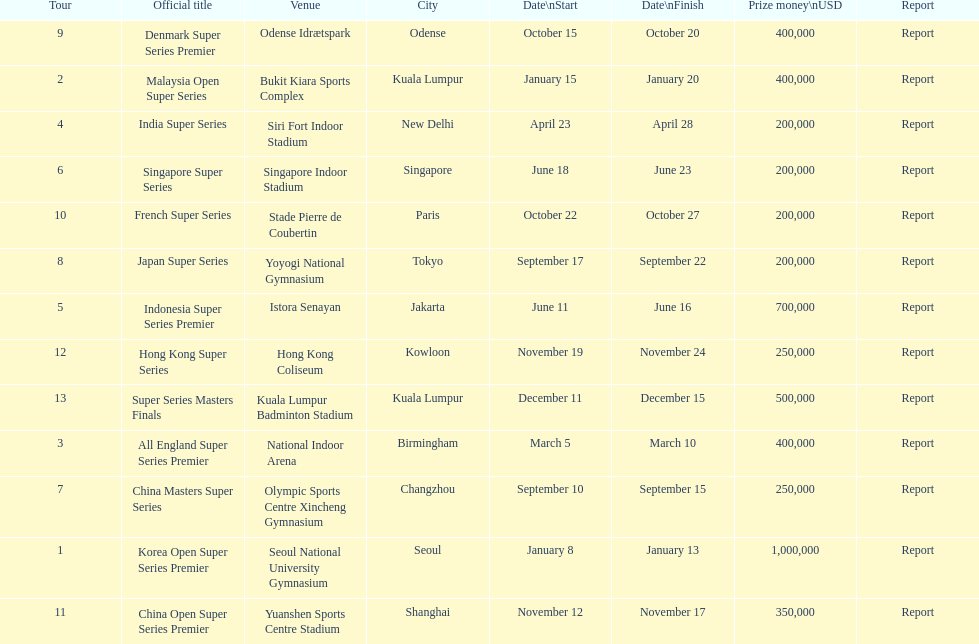How many events of the 2013 bwf super series pay over $200,000? 9. 